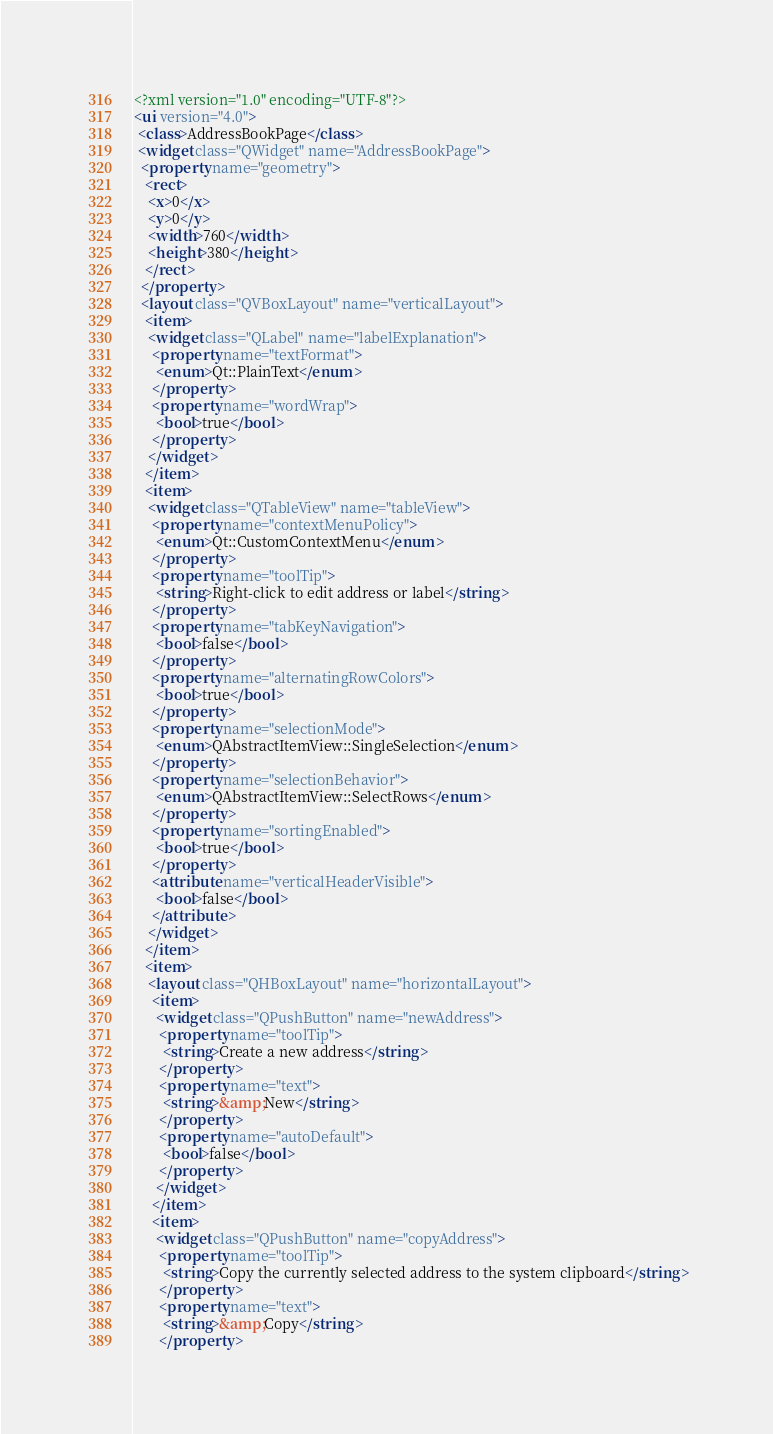<code> <loc_0><loc_0><loc_500><loc_500><_XML_><?xml version="1.0" encoding="UTF-8"?>
<ui version="4.0">
 <class>AddressBookPage</class>
 <widget class="QWidget" name="AddressBookPage">
  <property name="geometry">
   <rect>
    <x>0</x>
    <y>0</y>
    <width>760</width>
    <height>380</height>
   </rect>
  </property>
  <layout class="QVBoxLayout" name="verticalLayout">
   <item>
    <widget class="QLabel" name="labelExplanation">
     <property name="textFormat">
      <enum>Qt::PlainText</enum>
     </property>
     <property name="wordWrap">
      <bool>true</bool>
     </property>
    </widget>
   </item>
   <item>
    <widget class="QTableView" name="tableView">
     <property name="contextMenuPolicy">
      <enum>Qt::CustomContextMenu</enum>
     </property>
     <property name="toolTip">
      <string>Right-click to edit address or label</string>
     </property>
     <property name="tabKeyNavigation">
      <bool>false</bool>
     </property>
     <property name="alternatingRowColors">
      <bool>true</bool>
     </property>
     <property name="selectionMode">
      <enum>QAbstractItemView::SingleSelection</enum>
     </property>
     <property name="selectionBehavior">
      <enum>QAbstractItemView::SelectRows</enum>
     </property>
     <property name="sortingEnabled">
      <bool>true</bool>
     </property>
     <attribute name="verticalHeaderVisible">
      <bool>false</bool>
     </attribute>
    </widget>
   </item>
   <item>
    <layout class="QHBoxLayout" name="horizontalLayout">
     <item>
      <widget class="QPushButton" name="newAddress">
       <property name="toolTip">
        <string>Create a new address</string>
       </property>
       <property name="text">
        <string>&amp;New</string>
       </property>
       <property name="autoDefault">
        <bool>false</bool>
       </property>
      </widget>
     </item>
     <item>
      <widget class="QPushButton" name="copyAddress">
       <property name="toolTip">
        <string>Copy the currently selected address to the system clipboard</string>
       </property>
       <property name="text">
        <string>&amp;Copy</string>
       </property></code> 